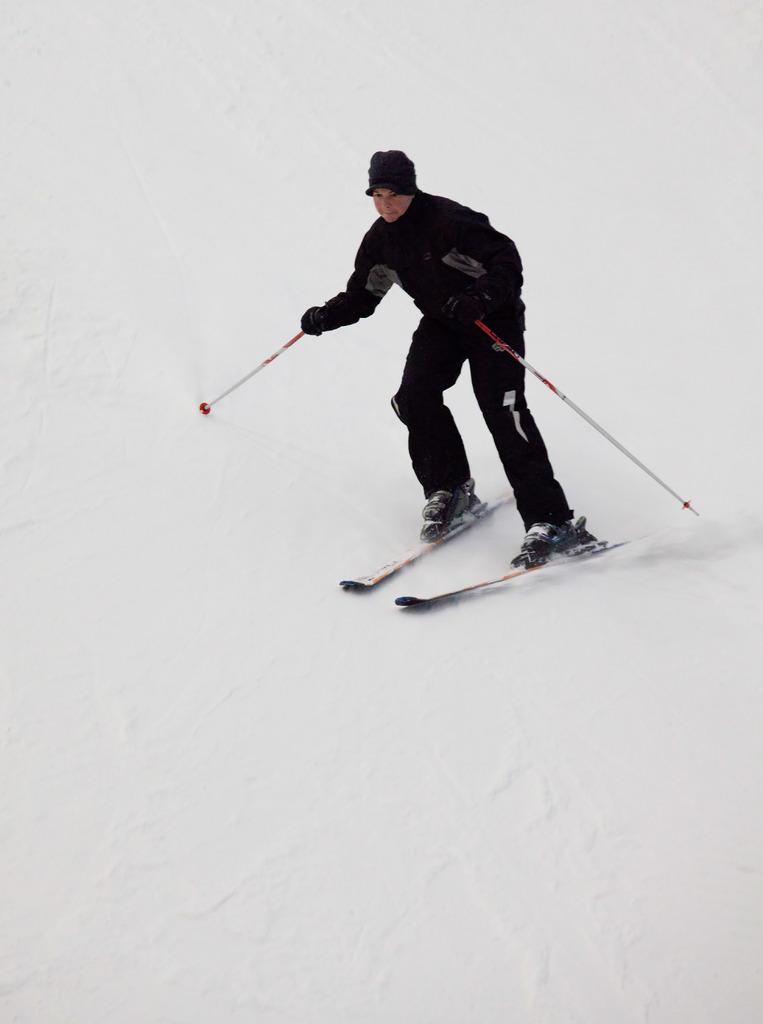Please provide a concise description of this image. In this picture we can see a person wore a cap, gloves and holding sticks and standing on skis and skiing on snow. 